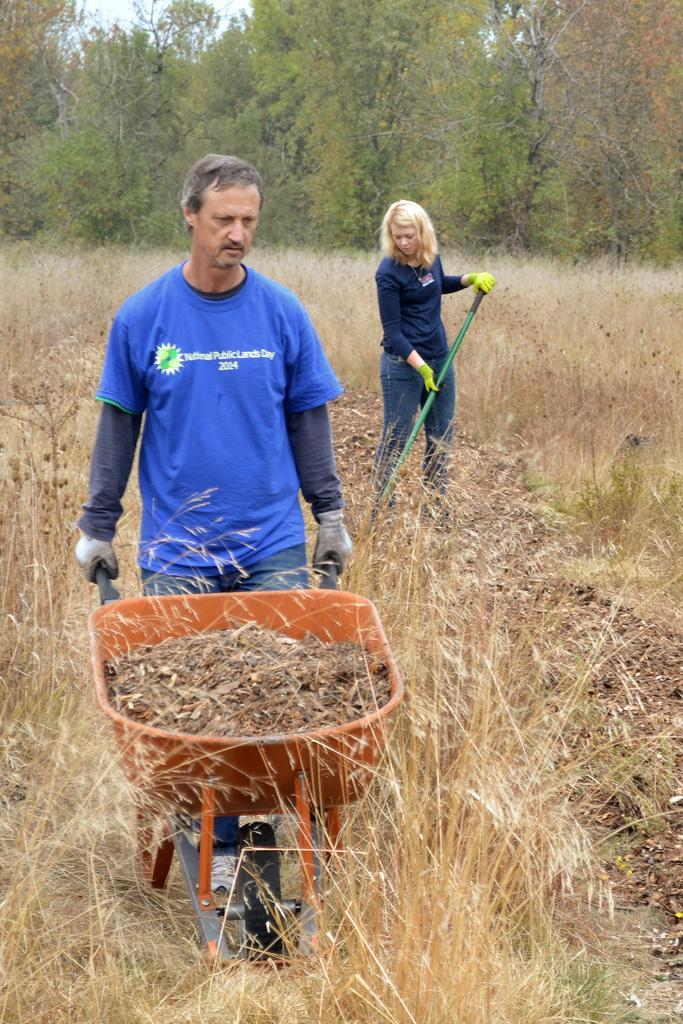What is the man in the image doing? The man is holding a trolley and moving it. Who else is present in the image? There is a woman in the image. Where is the woman located in relation to the man? The woman is in the background. What is the woman holding in the image? The woman is holding a stick. What can be seen in the background of the image? There is grass and trees in the background. What type of oranges can be seen in the image? There are no oranges present in the image. Is the man in the image the father of the woman? The relationship between the man and the woman is not mentioned in the image, so it cannot be determined if the man is the father of the woman. 